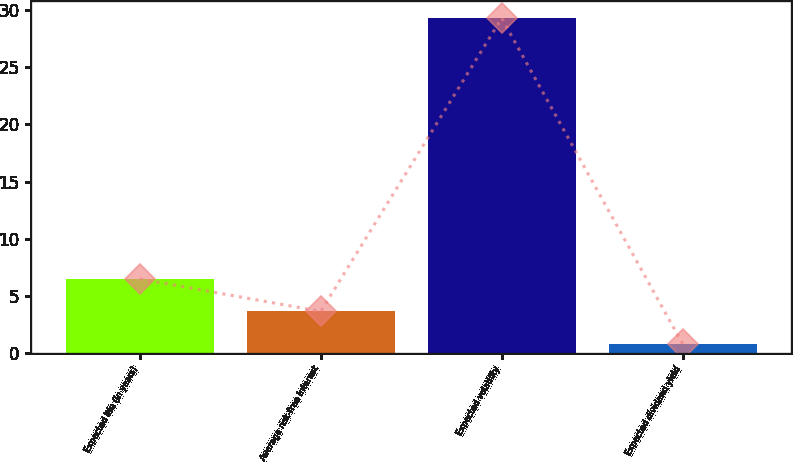Convert chart to OTSL. <chart><loc_0><loc_0><loc_500><loc_500><bar_chart><fcel>Expected life (in years)<fcel>Average risk-free interest<fcel>Expected volatility<fcel>Expected dividend yield<nl><fcel>6.49<fcel>3.64<fcel>29.3<fcel>0.79<nl></chart> 